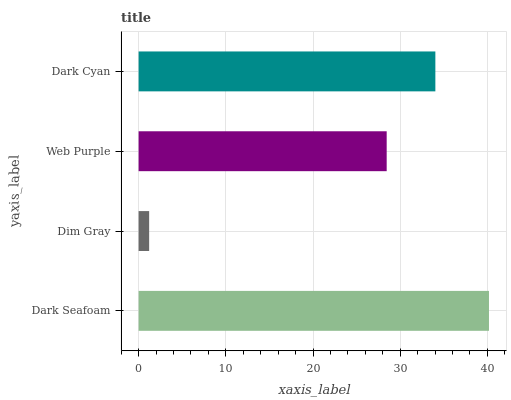Is Dim Gray the minimum?
Answer yes or no. Yes. Is Dark Seafoam the maximum?
Answer yes or no. Yes. Is Web Purple the minimum?
Answer yes or no. No. Is Web Purple the maximum?
Answer yes or no. No. Is Web Purple greater than Dim Gray?
Answer yes or no. Yes. Is Dim Gray less than Web Purple?
Answer yes or no. Yes. Is Dim Gray greater than Web Purple?
Answer yes or no. No. Is Web Purple less than Dim Gray?
Answer yes or no. No. Is Dark Cyan the high median?
Answer yes or no. Yes. Is Web Purple the low median?
Answer yes or no. Yes. Is Web Purple the high median?
Answer yes or no. No. Is Dark Cyan the low median?
Answer yes or no. No. 